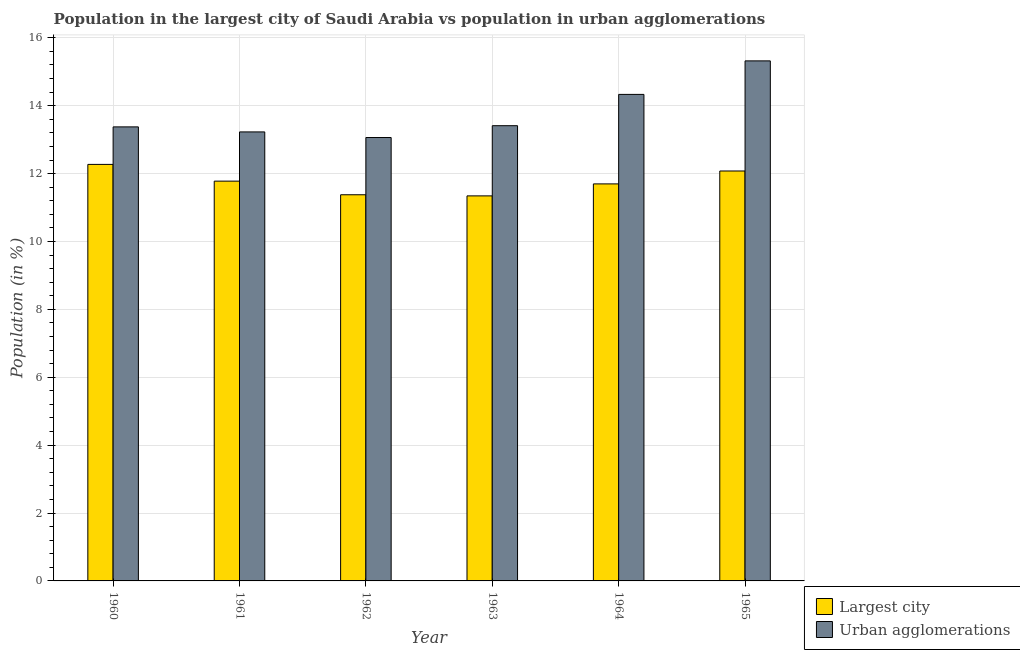How many groups of bars are there?
Provide a succinct answer. 6. How many bars are there on the 2nd tick from the left?
Provide a succinct answer. 2. How many bars are there on the 1st tick from the right?
Offer a very short reply. 2. What is the label of the 5th group of bars from the left?
Give a very brief answer. 1964. In how many cases, is the number of bars for a given year not equal to the number of legend labels?
Your answer should be compact. 0. What is the population in urban agglomerations in 1963?
Offer a very short reply. 13.41. Across all years, what is the maximum population in the largest city?
Provide a short and direct response. 12.27. Across all years, what is the minimum population in urban agglomerations?
Your response must be concise. 13.06. In which year was the population in urban agglomerations maximum?
Keep it short and to the point. 1965. What is the total population in the largest city in the graph?
Make the answer very short. 70.54. What is the difference between the population in the largest city in 1962 and that in 1964?
Offer a very short reply. -0.32. What is the difference between the population in the largest city in 1965 and the population in urban agglomerations in 1962?
Give a very brief answer. 0.7. What is the average population in the largest city per year?
Your response must be concise. 11.76. In the year 1960, what is the difference between the population in urban agglomerations and population in the largest city?
Keep it short and to the point. 0. What is the ratio of the population in urban agglomerations in 1962 to that in 1965?
Offer a terse response. 0.85. What is the difference between the highest and the second highest population in urban agglomerations?
Ensure brevity in your answer.  0.99. What is the difference between the highest and the lowest population in the largest city?
Your answer should be very brief. 0.93. In how many years, is the population in the largest city greater than the average population in the largest city taken over all years?
Ensure brevity in your answer.  3. Is the sum of the population in urban agglomerations in 1960 and 1961 greater than the maximum population in the largest city across all years?
Give a very brief answer. Yes. What does the 1st bar from the left in 1965 represents?
Offer a terse response. Largest city. What does the 1st bar from the right in 1962 represents?
Your answer should be very brief. Urban agglomerations. How many bars are there?
Offer a very short reply. 12. How many years are there in the graph?
Offer a very short reply. 6. What is the difference between two consecutive major ticks on the Y-axis?
Provide a succinct answer. 2. Where does the legend appear in the graph?
Your answer should be very brief. Bottom right. How many legend labels are there?
Your answer should be compact. 2. How are the legend labels stacked?
Your answer should be compact. Vertical. What is the title of the graph?
Ensure brevity in your answer.  Population in the largest city of Saudi Arabia vs population in urban agglomerations. What is the label or title of the Y-axis?
Offer a terse response. Population (in %). What is the Population (in %) in Largest city in 1960?
Give a very brief answer. 12.27. What is the Population (in %) of Urban agglomerations in 1960?
Give a very brief answer. 13.38. What is the Population (in %) of Largest city in 1961?
Your answer should be very brief. 11.78. What is the Population (in %) in Urban agglomerations in 1961?
Give a very brief answer. 13.23. What is the Population (in %) of Largest city in 1962?
Provide a short and direct response. 11.38. What is the Population (in %) of Urban agglomerations in 1962?
Make the answer very short. 13.06. What is the Population (in %) of Largest city in 1963?
Offer a very short reply. 11.34. What is the Population (in %) of Urban agglomerations in 1963?
Provide a succinct answer. 13.41. What is the Population (in %) of Largest city in 1964?
Your answer should be compact. 11.7. What is the Population (in %) of Urban agglomerations in 1964?
Ensure brevity in your answer.  14.33. What is the Population (in %) of Largest city in 1965?
Offer a very short reply. 12.08. What is the Population (in %) in Urban agglomerations in 1965?
Provide a short and direct response. 15.32. Across all years, what is the maximum Population (in %) of Largest city?
Make the answer very short. 12.27. Across all years, what is the maximum Population (in %) of Urban agglomerations?
Offer a very short reply. 15.32. Across all years, what is the minimum Population (in %) of Largest city?
Your response must be concise. 11.34. Across all years, what is the minimum Population (in %) in Urban agglomerations?
Ensure brevity in your answer.  13.06. What is the total Population (in %) of Largest city in the graph?
Offer a terse response. 70.54. What is the total Population (in %) in Urban agglomerations in the graph?
Your answer should be compact. 82.73. What is the difference between the Population (in %) in Largest city in 1960 and that in 1961?
Your response must be concise. 0.49. What is the difference between the Population (in %) of Urban agglomerations in 1960 and that in 1961?
Make the answer very short. 0.15. What is the difference between the Population (in %) in Largest city in 1960 and that in 1962?
Your answer should be very brief. 0.89. What is the difference between the Population (in %) of Urban agglomerations in 1960 and that in 1962?
Provide a succinct answer. 0.31. What is the difference between the Population (in %) in Largest city in 1960 and that in 1963?
Offer a terse response. 0.93. What is the difference between the Population (in %) in Urban agglomerations in 1960 and that in 1963?
Offer a very short reply. -0.03. What is the difference between the Population (in %) of Largest city in 1960 and that in 1964?
Ensure brevity in your answer.  0.57. What is the difference between the Population (in %) in Urban agglomerations in 1960 and that in 1964?
Give a very brief answer. -0.96. What is the difference between the Population (in %) of Largest city in 1960 and that in 1965?
Provide a succinct answer. 0.19. What is the difference between the Population (in %) of Urban agglomerations in 1960 and that in 1965?
Ensure brevity in your answer.  -1.94. What is the difference between the Population (in %) of Largest city in 1961 and that in 1962?
Keep it short and to the point. 0.4. What is the difference between the Population (in %) of Urban agglomerations in 1961 and that in 1962?
Your answer should be very brief. 0.17. What is the difference between the Population (in %) in Largest city in 1961 and that in 1963?
Provide a short and direct response. 0.43. What is the difference between the Population (in %) of Urban agglomerations in 1961 and that in 1963?
Your response must be concise. -0.18. What is the difference between the Population (in %) in Largest city in 1961 and that in 1964?
Offer a very short reply. 0.08. What is the difference between the Population (in %) in Urban agglomerations in 1961 and that in 1964?
Your answer should be very brief. -1.11. What is the difference between the Population (in %) in Largest city in 1961 and that in 1965?
Offer a very short reply. -0.3. What is the difference between the Population (in %) in Urban agglomerations in 1961 and that in 1965?
Make the answer very short. -2.09. What is the difference between the Population (in %) of Largest city in 1962 and that in 1963?
Offer a very short reply. 0.03. What is the difference between the Population (in %) in Urban agglomerations in 1962 and that in 1963?
Provide a short and direct response. -0.35. What is the difference between the Population (in %) in Largest city in 1962 and that in 1964?
Your answer should be very brief. -0.32. What is the difference between the Population (in %) in Urban agglomerations in 1962 and that in 1964?
Make the answer very short. -1.27. What is the difference between the Population (in %) in Largest city in 1962 and that in 1965?
Provide a succinct answer. -0.7. What is the difference between the Population (in %) in Urban agglomerations in 1962 and that in 1965?
Keep it short and to the point. -2.26. What is the difference between the Population (in %) in Largest city in 1963 and that in 1964?
Make the answer very short. -0.35. What is the difference between the Population (in %) of Urban agglomerations in 1963 and that in 1964?
Make the answer very short. -0.92. What is the difference between the Population (in %) in Largest city in 1963 and that in 1965?
Offer a terse response. -0.73. What is the difference between the Population (in %) in Urban agglomerations in 1963 and that in 1965?
Your answer should be compact. -1.91. What is the difference between the Population (in %) of Largest city in 1964 and that in 1965?
Your answer should be very brief. -0.38. What is the difference between the Population (in %) in Urban agglomerations in 1964 and that in 1965?
Offer a very short reply. -0.99. What is the difference between the Population (in %) of Largest city in 1960 and the Population (in %) of Urban agglomerations in 1961?
Your answer should be compact. -0.96. What is the difference between the Population (in %) in Largest city in 1960 and the Population (in %) in Urban agglomerations in 1962?
Give a very brief answer. -0.79. What is the difference between the Population (in %) in Largest city in 1960 and the Population (in %) in Urban agglomerations in 1963?
Give a very brief answer. -1.14. What is the difference between the Population (in %) of Largest city in 1960 and the Population (in %) of Urban agglomerations in 1964?
Offer a very short reply. -2.06. What is the difference between the Population (in %) in Largest city in 1960 and the Population (in %) in Urban agglomerations in 1965?
Offer a terse response. -3.05. What is the difference between the Population (in %) of Largest city in 1961 and the Population (in %) of Urban agglomerations in 1962?
Provide a succinct answer. -1.28. What is the difference between the Population (in %) in Largest city in 1961 and the Population (in %) in Urban agglomerations in 1963?
Your answer should be compact. -1.63. What is the difference between the Population (in %) of Largest city in 1961 and the Population (in %) of Urban agglomerations in 1964?
Provide a short and direct response. -2.56. What is the difference between the Population (in %) of Largest city in 1961 and the Population (in %) of Urban agglomerations in 1965?
Your answer should be very brief. -3.54. What is the difference between the Population (in %) of Largest city in 1962 and the Population (in %) of Urban agglomerations in 1963?
Provide a succinct answer. -2.03. What is the difference between the Population (in %) in Largest city in 1962 and the Population (in %) in Urban agglomerations in 1964?
Keep it short and to the point. -2.96. What is the difference between the Population (in %) in Largest city in 1962 and the Population (in %) in Urban agglomerations in 1965?
Ensure brevity in your answer.  -3.94. What is the difference between the Population (in %) of Largest city in 1963 and the Population (in %) of Urban agglomerations in 1964?
Ensure brevity in your answer.  -2.99. What is the difference between the Population (in %) in Largest city in 1963 and the Population (in %) in Urban agglomerations in 1965?
Give a very brief answer. -3.98. What is the difference between the Population (in %) of Largest city in 1964 and the Population (in %) of Urban agglomerations in 1965?
Your response must be concise. -3.62. What is the average Population (in %) of Largest city per year?
Your answer should be compact. 11.76. What is the average Population (in %) of Urban agglomerations per year?
Give a very brief answer. 13.79. In the year 1960, what is the difference between the Population (in %) of Largest city and Population (in %) of Urban agglomerations?
Offer a terse response. -1.11. In the year 1961, what is the difference between the Population (in %) in Largest city and Population (in %) in Urban agglomerations?
Provide a succinct answer. -1.45. In the year 1962, what is the difference between the Population (in %) of Largest city and Population (in %) of Urban agglomerations?
Provide a short and direct response. -1.69. In the year 1963, what is the difference between the Population (in %) of Largest city and Population (in %) of Urban agglomerations?
Offer a very short reply. -2.07. In the year 1964, what is the difference between the Population (in %) of Largest city and Population (in %) of Urban agglomerations?
Ensure brevity in your answer.  -2.64. In the year 1965, what is the difference between the Population (in %) in Largest city and Population (in %) in Urban agglomerations?
Provide a succinct answer. -3.24. What is the ratio of the Population (in %) in Largest city in 1960 to that in 1961?
Give a very brief answer. 1.04. What is the ratio of the Population (in %) in Urban agglomerations in 1960 to that in 1961?
Your answer should be very brief. 1.01. What is the ratio of the Population (in %) of Largest city in 1960 to that in 1962?
Your answer should be compact. 1.08. What is the ratio of the Population (in %) of Largest city in 1960 to that in 1963?
Offer a very short reply. 1.08. What is the ratio of the Population (in %) in Urban agglomerations in 1960 to that in 1963?
Keep it short and to the point. 1. What is the ratio of the Population (in %) in Largest city in 1960 to that in 1964?
Ensure brevity in your answer.  1.05. What is the ratio of the Population (in %) in Urban agglomerations in 1960 to that in 1964?
Offer a very short reply. 0.93. What is the ratio of the Population (in %) of Largest city in 1960 to that in 1965?
Your answer should be compact. 1.02. What is the ratio of the Population (in %) in Urban agglomerations in 1960 to that in 1965?
Your answer should be very brief. 0.87. What is the ratio of the Population (in %) in Largest city in 1961 to that in 1962?
Offer a very short reply. 1.04. What is the ratio of the Population (in %) in Urban agglomerations in 1961 to that in 1962?
Ensure brevity in your answer.  1.01. What is the ratio of the Population (in %) of Largest city in 1961 to that in 1963?
Keep it short and to the point. 1.04. What is the ratio of the Population (in %) in Urban agglomerations in 1961 to that in 1963?
Give a very brief answer. 0.99. What is the ratio of the Population (in %) in Largest city in 1961 to that in 1964?
Make the answer very short. 1.01. What is the ratio of the Population (in %) in Urban agglomerations in 1961 to that in 1964?
Keep it short and to the point. 0.92. What is the ratio of the Population (in %) in Largest city in 1961 to that in 1965?
Provide a short and direct response. 0.98. What is the ratio of the Population (in %) in Urban agglomerations in 1961 to that in 1965?
Provide a succinct answer. 0.86. What is the ratio of the Population (in %) in Urban agglomerations in 1962 to that in 1963?
Your response must be concise. 0.97. What is the ratio of the Population (in %) in Largest city in 1962 to that in 1964?
Your answer should be very brief. 0.97. What is the ratio of the Population (in %) of Urban agglomerations in 1962 to that in 1964?
Ensure brevity in your answer.  0.91. What is the ratio of the Population (in %) of Largest city in 1962 to that in 1965?
Offer a terse response. 0.94. What is the ratio of the Population (in %) of Urban agglomerations in 1962 to that in 1965?
Your response must be concise. 0.85. What is the ratio of the Population (in %) of Largest city in 1963 to that in 1964?
Provide a succinct answer. 0.97. What is the ratio of the Population (in %) of Urban agglomerations in 1963 to that in 1964?
Offer a terse response. 0.94. What is the ratio of the Population (in %) in Largest city in 1963 to that in 1965?
Provide a succinct answer. 0.94. What is the ratio of the Population (in %) in Urban agglomerations in 1963 to that in 1965?
Give a very brief answer. 0.88. What is the ratio of the Population (in %) in Largest city in 1964 to that in 1965?
Make the answer very short. 0.97. What is the ratio of the Population (in %) in Urban agglomerations in 1964 to that in 1965?
Offer a very short reply. 0.94. What is the difference between the highest and the second highest Population (in %) of Largest city?
Give a very brief answer. 0.19. What is the difference between the highest and the second highest Population (in %) in Urban agglomerations?
Make the answer very short. 0.99. What is the difference between the highest and the lowest Population (in %) of Largest city?
Your answer should be very brief. 0.93. What is the difference between the highest and the lowest Population (in %) in Urban agglomerations?
Provide a short and direct response. 2.26. 